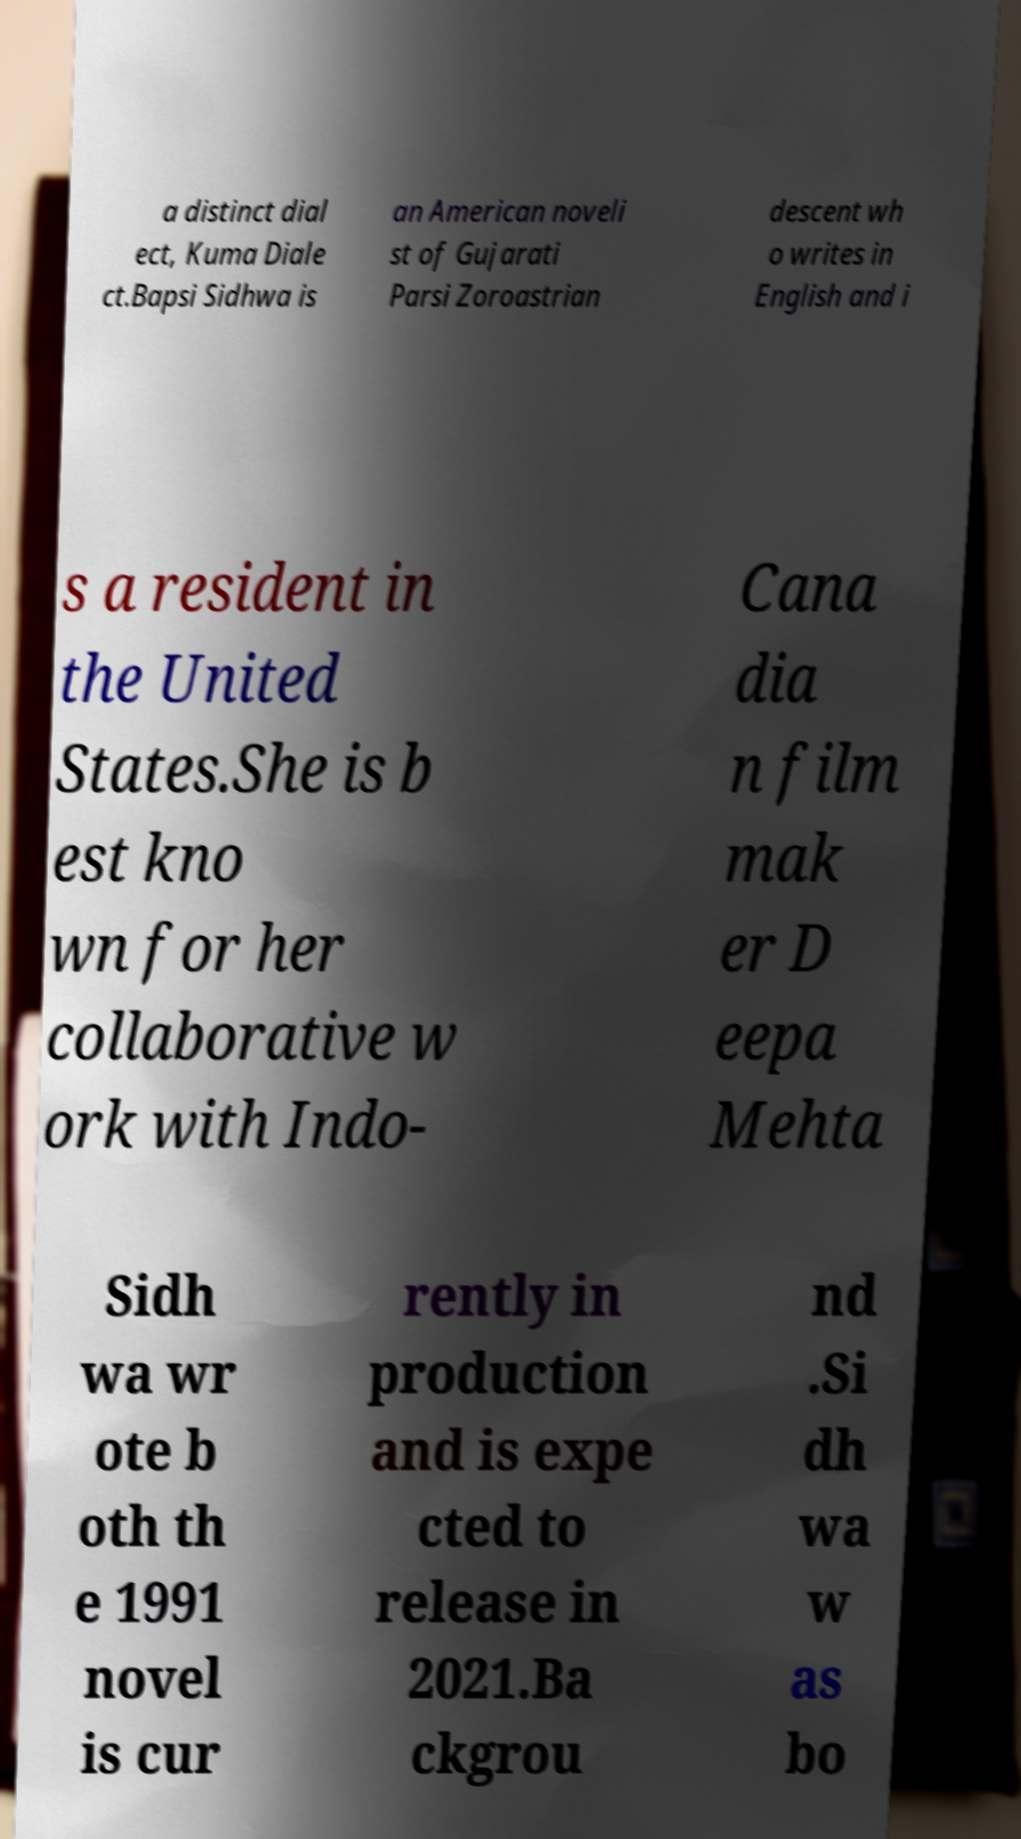Can you read and provide the text displayed in the image?This photo seems to have some interesting text. Can you extract and type it out for me? a distinct dial ect, Kuma Diale ct.Bapsi Sidhwa is an American noveli st of Gujarati Parsi Zoroastrian descent wh o writes in English and i s a resident in the United States.She is b est kno wn for her collaborative w ork with Indo- Cana dia n film mak er D eepa Mehta Sidh wa wr ote b oth th e 1991 novel is cur rently in production and is expe cted to release in 2021.Ba ckgrou nd .Si dh wa w as bo 